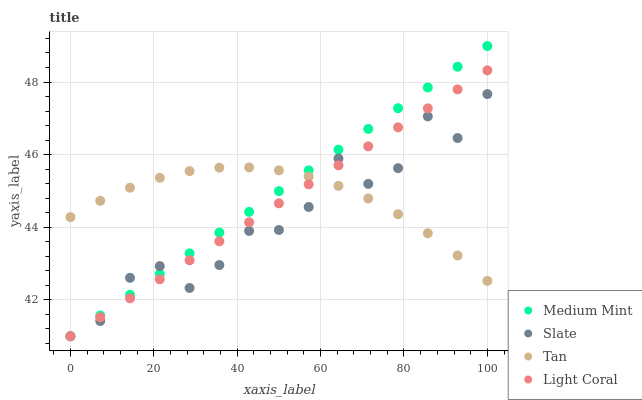Does Slate have the minimum area under the curve?
Answer yes or no. Yes. Does Medium Mint have the maximum area under the curve?
Answer yes or no. Yes. Does Light Coral have the minimum area under the curve?
Answer yes or no. No. Does Light Coral have the maximum area under the curve?
Answer yes or no. No. Is Medium Mint the smoothest?
Answer yes or no. Yes. Is Slate the roughest?
Answer yes or no. Yes. Is Light Coral the smoothest?
Answer yes or no. No. Is Light Coral the roughest?
Answer yes or no. No. Does Medium Mint have the lowest value?
Answer yes or no. Yes. Does Tan have the lowest value?
Answer yes or no. No. Does Medium Mint have the highest value?
Answer yes or no. Yes. Does Light Coral have the highest value?
Answer yes or no. No. Does Light Coral intersect Slate?
Answer yes or no. Yes. Is Light Coral less than Slate?
Answer yes or no. No. Is Light Coral greater than Slate?
Answer yes or no. No. 